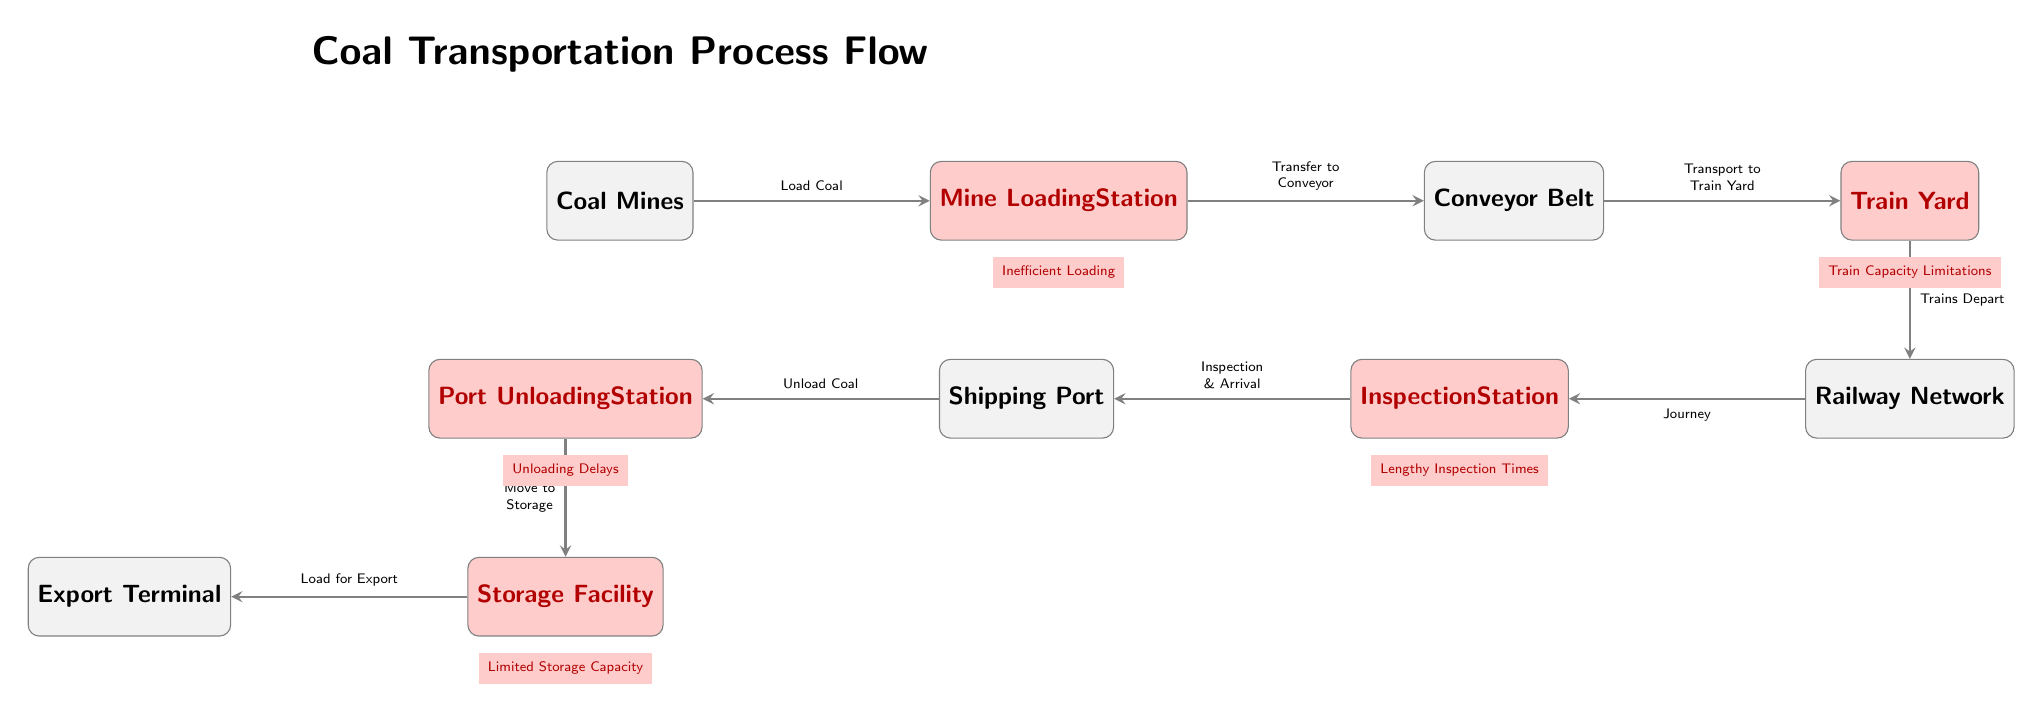What is the first node in the flow? The diagram starts with the "Coal Mines" node, which is the first step in the coal transportation process. By following the arrows back from the first action, we identify "Coal Mines" as the starting point.
Answer: Coal Mines How many bottlenecks are identified in the process? The diagram highlights five areas labeled as bottlenecks: Mine Loading Station, Train Yard, Inspection Station, Port Unloading Station, and Storage Facility. By counting these labeled areas, we find there are five bottlenecks in total.
Answer: 5 What is the primary action occurring at the Train Yard? The primary action indicated at the Train Yard is "Trains Depart." This is reflected in the label along the arrow transitioning from the Train Yard node.
Answer: Trains Depart Which node is directly connected to the Inspection Station? The Inspection Station is directly connected to the Railway Network, as shown by the arrow that flows from the Railway Network node to the Inspection Station.
Answer: Railway Network What does the diagram suggest causes delays in the unloading process? The diagram indicates "Unloading Delays" as a bottleneck in the Port Unloading Station. This label directly identifies the cause of delays in the unloading process.
Answer: Unloading Delays Which node follows the Conveyor Belt in the flow? The node that follows the Conveyor Belt in the flow is the Train Yard. This can be traced by following the arrow from the Conveyor Belt node to the Train Yard node.
Answer: Train Yard What issues are noted at the Storage Facility? The issue noted at the Storage Facility is "Limited Storage Capacity," as indicated by the bottleneck label present below the Storage Facility node.
Answer: Limited Storage Capacity What is the relationship between the Mining Loading Station and the Conveyor Belt? The Mining Loading Station is connected to the Conveyor Belt through the action of "Transfer to Conveyor," indicating that the loading process is followed by transferring coal via the conveyor.
Answer: Transfer to Conveyor 